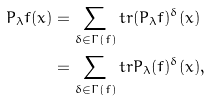<formula> <loc_0><loc_0><loc_500><loc_500>P _ { \lambda } f ( x ) & = \sum _ { \delta \in \Gamma ( f ) } t r ( P _ { \lambda } f ) ^ { \delta } ( x ) \\ & = \sum _ { \delta \in \Gamma ( f ) } t r P _ { \lambda } ( f ) ^ { \delta } ( x ) ,</formula> 